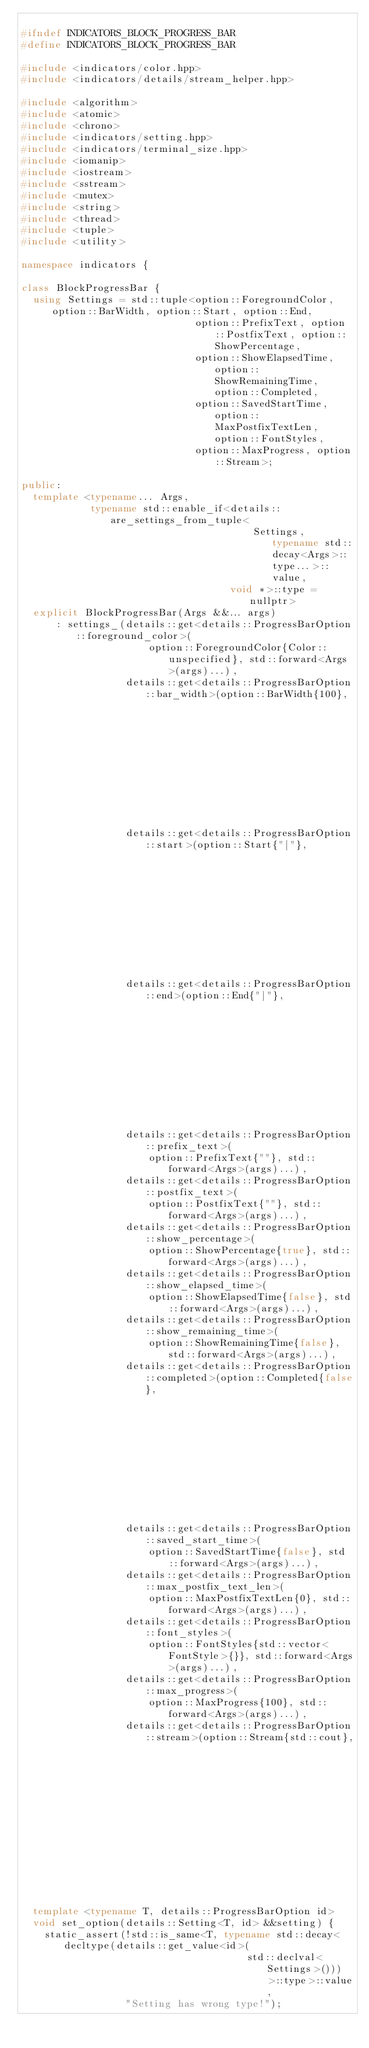<code> <loc_0><loc_0><loc_500><loc_500><_C++_>
#ifndef INDICATORS_BLOCK_PROGRESS_BAR
#define INDICATORS_BLOCK_PROGRESS_BAR

#include <indicators/color.hpp>
#include <indicators/details/stream_helper.hpp>

#include <algorithm>
#include <atomic>
#include <chrono>
#include <indicators/setting.hpp>
#include <indicators/terminal_size.hpp>
#include <iomanip>
#include <iostream>
#include <sstream>
#include <mutex>
#include <string>
#include <thread>
#include <tuple>
#include <utility>

namespace indicators {

class BlockProgressBar {
  using Settings = std::tuple<option::ForegroundColor, option::BarWidth, option::Start, option::End,
                              option::PrefixText, option::PostfixText, option::ShowPercentage,
                              option::ShowElapsedTime, option::ShowRemainingTime, option::Completed,
                              option::SavedStartTime, option::MaxPostfixTextLen, option::FontStyles,
                              option::MaxProgress, option::Stream>;

public:
  template <typename... Args,
            typename std::enable_if<details::are_settings_from_tuple<
                                        Settings, typename std::decay<Args>::type...>::value,
                                    void *>::type = nullptr>
  explicit BlockProgressBar(Args &&... args)
      : settings_(details::get<details::ProgressBarOption::foreground_color>(
                      option::ForegroundColor{Color::unspecified}, std::forward<Args>(args)...),
                  details::get<details::ProgressBarOption::bar_width>(option::BarWidth{100},
                                                                      std::forward<Args>(args)...),
                  details::get<details::ProgressBarOption::start>(option::Start{"["},
                                                                  std::forward<Args>(args)...),
                  details::get<details::ProgressBarOption::end>(option::End{"]"},
                                                                std::forward<Args>(args)...),
                  details::get<details::ProgressBarOption::prefix_text>(
                      option::PrefixText{""}, std::forward<Args>(args)...),
                  details::get<details::ProgressBarOption::postfix_text>(
                      option::PostfixText{""}, std::forward<Args>(args)...),
                  details::get<details::ProgressBarOption::show_percentage>(
                      option::ShowPercentage{true}, std::forward<Args>(args)...),
                  details::get<details::ProgressBarOption::show_elapsed_time>(
                      option::ShowElapsedTime{false}, std::forward<Args>(args)...),
                  details::get<details::ProgressBarOption::show_remaining_time>(
                      option::ShowRemainingTime{false}, std::forward<Args>(args)...),
                  details::get<details::ProgressBarOption::completed>(option::Completed{false},
                                                                      std::forward<Args>(args)...),
                  details::get<details::ProgressBarOption::saved_start_time>(
                      option::SavedStartTime{false}, std::forward<Args>(args)...),
                  details::get<details::ProgressBarOption::max_postfix_text_len>(
                      option::MaxPostfixTextLen{0}, std::forward<Args>(args)...),
                  details::get<details::ProgressBarOption::font_styles>(
                      option::FontStyles{std::vector<FontStyle>{}}, std::forward<Args>(args)...),
                  details::get<details::ProgressBarOption::max_progress>(
                      option::MaxProgress{100}, std::forward<Args>(args)...),
                  details::get<details::ProgressBarOption::stream>(option::Stream{std::cout},
                                                                   std::forward<Args>(args)...)) {}

  template <typename T, details::ProgressBarOption id>
  void set_option(details::Setting<T, id> &&setting) {
    static_assert(!std::is_same<T, typename std::decay<decltype(details::get_value<id>(
                                       std::declval<Settings>()))>::type>::value,
                  "Setting has wrong type!");</code> 